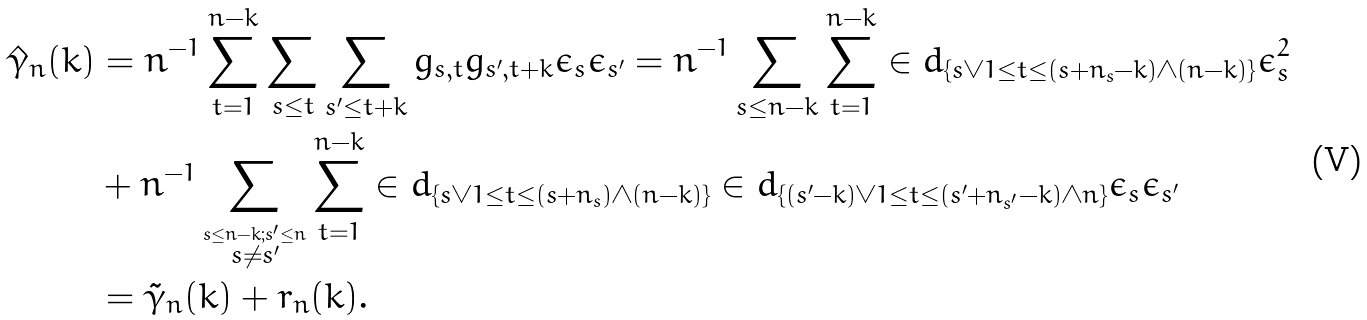Convert formula to latex. <formula><loc_0><loc_0><loc_500><loc_500>\hat { \gamma } _ { n } ( k ) & = n ^ { - 1 } \sum _ { t = 1 } ^ { n - k } \sum _ { s \leq t } \sum _ { s ^ { \prime } \leq t + k } g _ { s , t } g _ { s ^ { \prime } , t + k } \epsilon _ { s } \epsilon _ { s ^ { \prime } } = n ^ { - 1 } \sum _ { s \leq n - k } \sum _ { t = 1 } ^ { n - k } \in d _ { \{ s \vee 1 \leq t \leq ( s + n _ { s } - k ) \wedge ( n - k ) \} } \epsilon _ { s } ^ { 2 } \\ & + n ^ { - 1 } \sum _ { \stackrel { s \leq n - k ; s ^ { \prime } \leq n } { s \ne s ^ { \prime } } } \sum _ { t = 1 } ^ { n - k } \in d _ { \{ s \vee 1 \leq t \leq ( s + n _ { s } ) \wedge ( n - k ) \} } \in d _ { \{ ( s ^ { \prime } - k ) \vee 1 \leq t \leq ( s ^ { \prime } + n _ { s ^ { \prime } } - k ) \wedge n \} } \epsilon _ { s } \epsilon _ { s ^ { \prime } } \\ & = \tilde { \gamma } _ { n } ( k ) + r _ { n } ( k ) .</formula> 